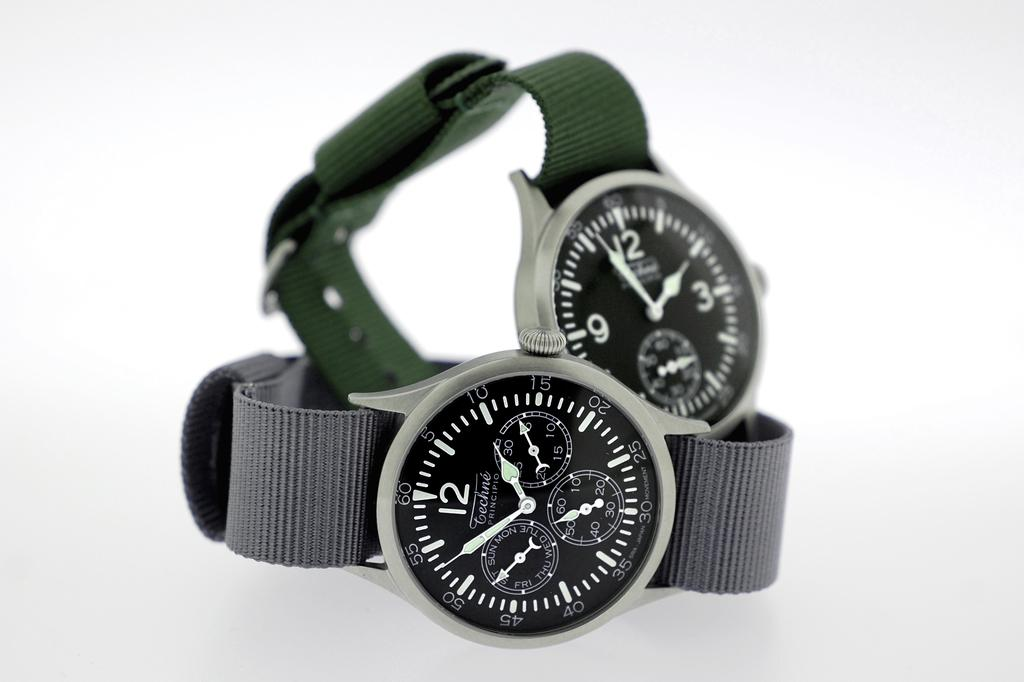Provide a one-sentence caption for the provided image. Watches that are both set to two o clock and 3 o clock. 